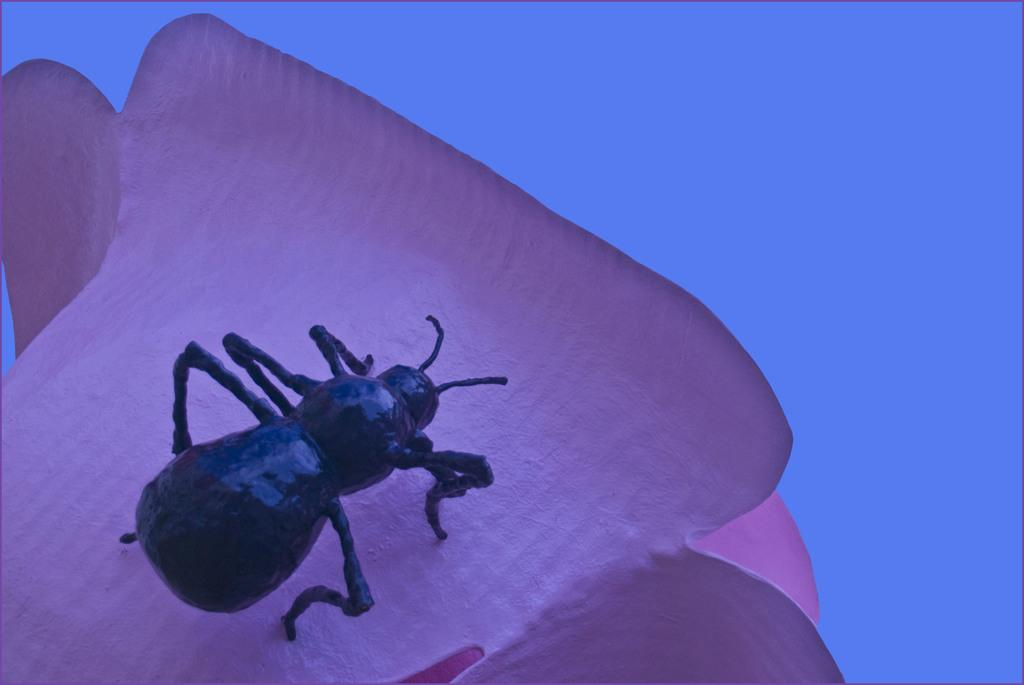What is present on the flower in the image? There is a bug on the flower in the image. What color is the flower that the bug is on? The flower is pink in color. What can be seen in the background of the image? There is a blue color visible in the background of the image. Who is the creator of the station that the bug is on in the image? There is no station present in the image, and therefore no creator can be identified. 